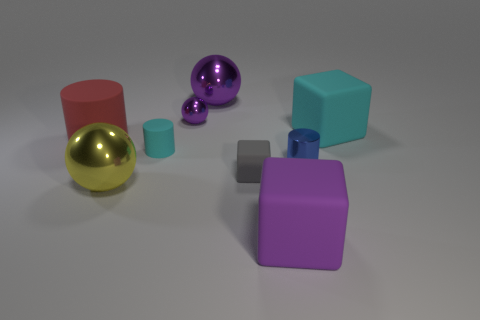Subtract all purple balls. How many balls are left? 1 Add 1 purple objects. How many objects exist? 10 Subtract all cylinders. How many objects are left? 6 Subtract 0 blue cubes. How many objects are left? 9 Subtract all big purple matte blocks. Subtract all cyan rubber things. How many objects are left? 6 Add 6 tiny rubber cubes. How many tiny rubber cubes are left? 7 Add 7 small cyan cylinders. How many small cyan cylinders exist? 8 